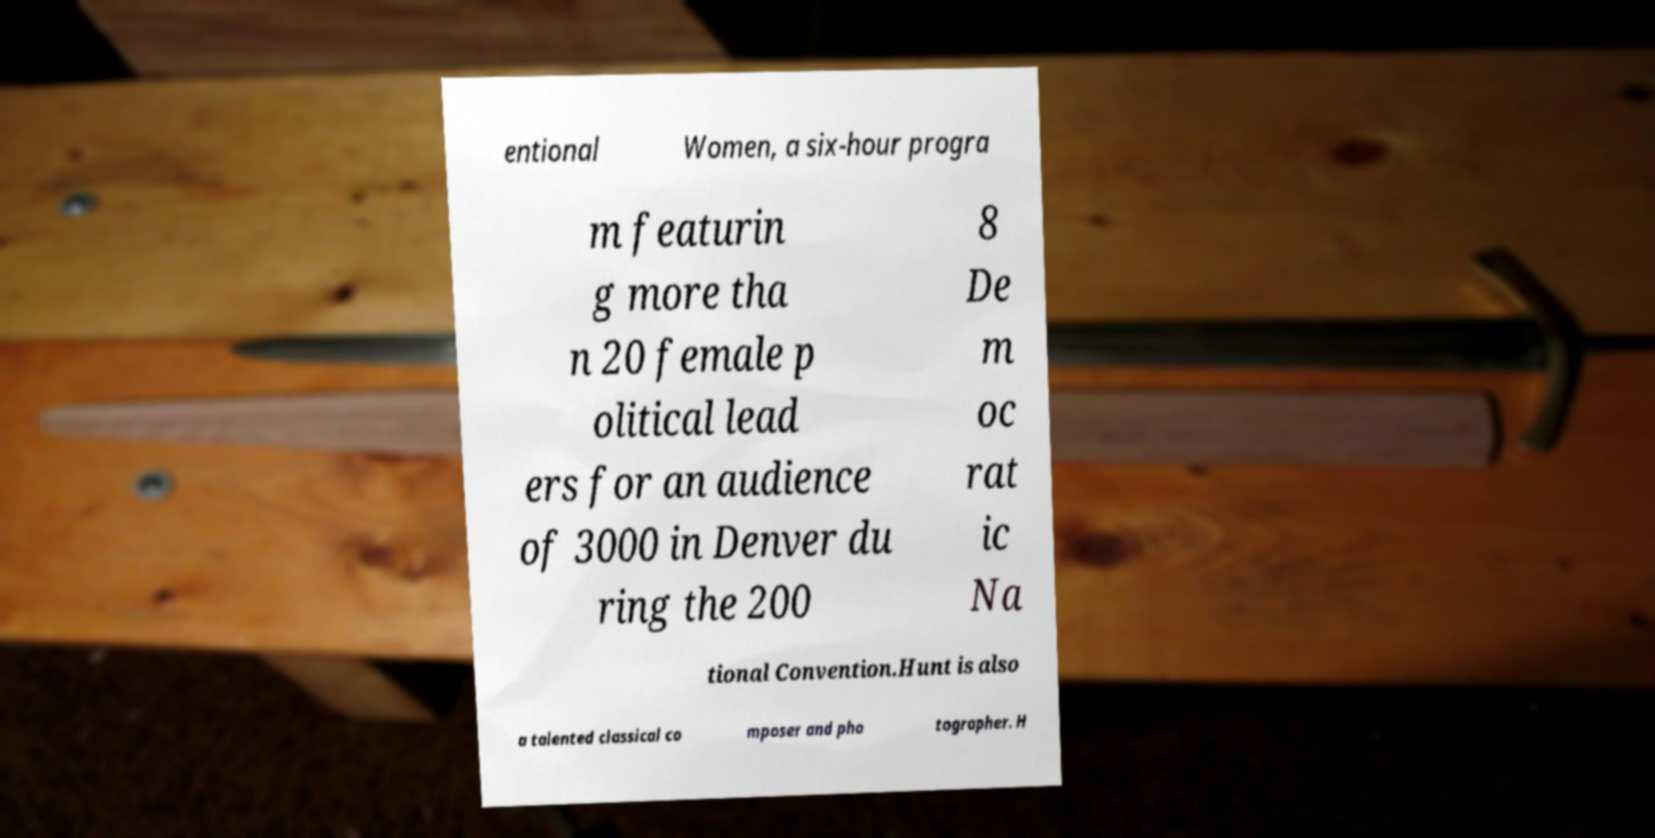There's text embedded in this image that I need extracted. Can you transcribe it verbatim? entional Women, a six-hour progra m featurin g more tha n 20 female p olitical lead ers for an audience of 3000 in Denver du ring the 200 8 De m oc rat ic Na tional Convention.Hunt is also a talented classical co mposer and pho tographer. H 